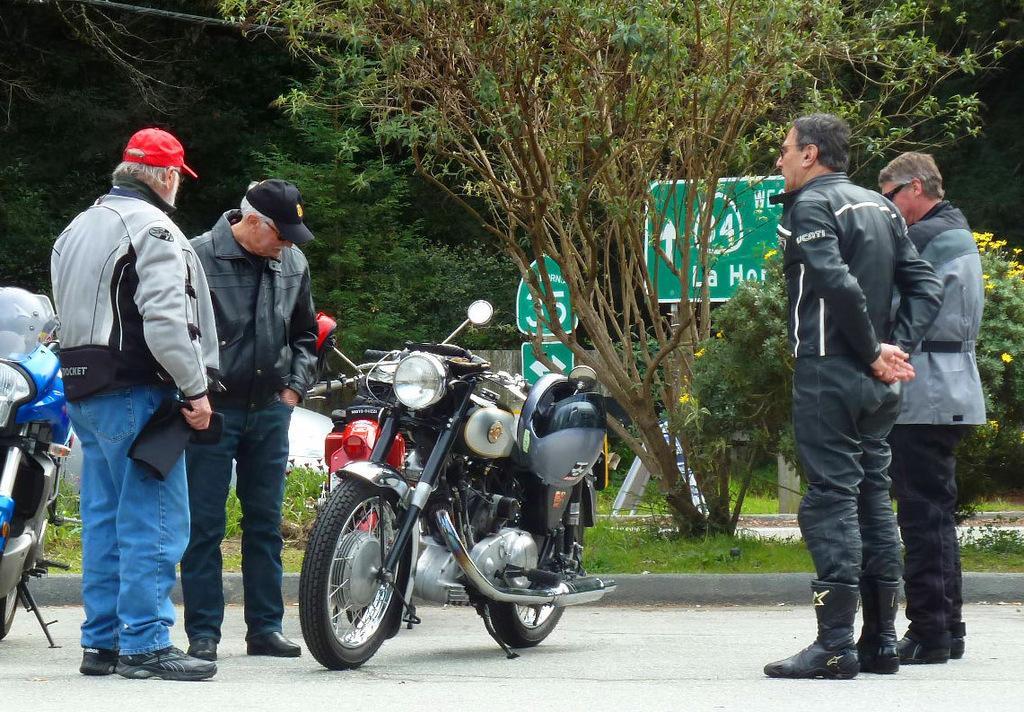How would you summarize this image in a sentence or two? In this image there are few bikes and people standing on the road, behind them there are so many plants, trees and boards on the pole. 